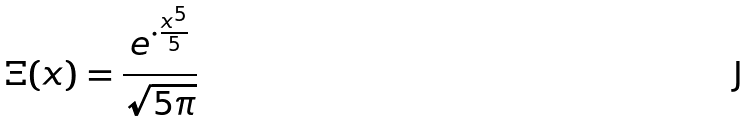<formula> <loc_0><loc_0><loc_500><loc_500>\Xi ( x ) = \frac { e ^ { \cdot \frac { x ^ { 5 } } { 5 } } } { \sqrt { 5 \pi } }</formula> 